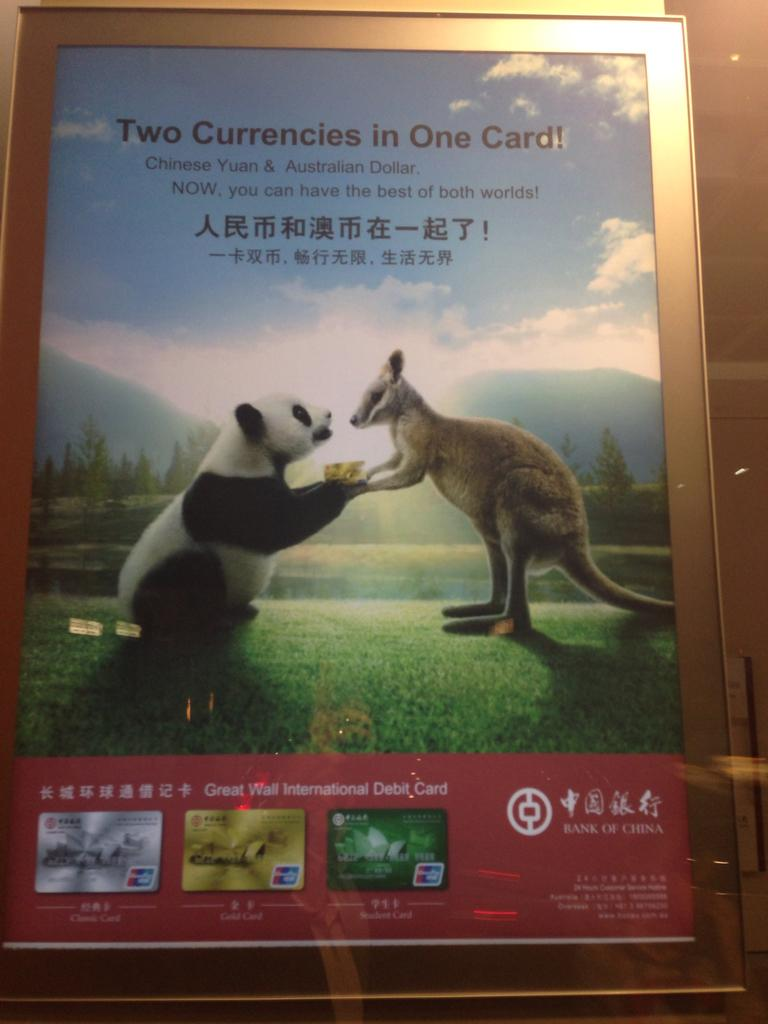What is on the wall in the image? There is a board on the wall in the image. What else can be seen in the image besides the board? There are lights in the image. What is written or displayed on the board? The board contains text and pictures. How much snow is visible on the board in the image? There is no snow present on the board or in the image. What type of box is used to store the lights in the image? There is no box present in the image; the lights are hanging from the ceiling or wall. 